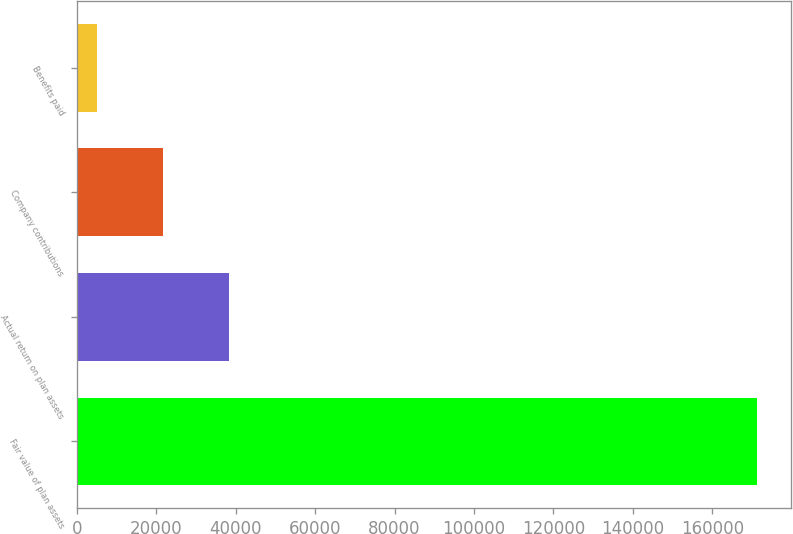<chart> <loc_0><loc_0><loc_500><loc_500><bar_chart><fcel>Fair value of plan assets<fcel>Actual return on plan assets<fcel>Company contributions<fcel>Benefits paid<nl><fcel>171373<fcel>38321<fcel>21689.5<fcel>5058<nl></chart> 